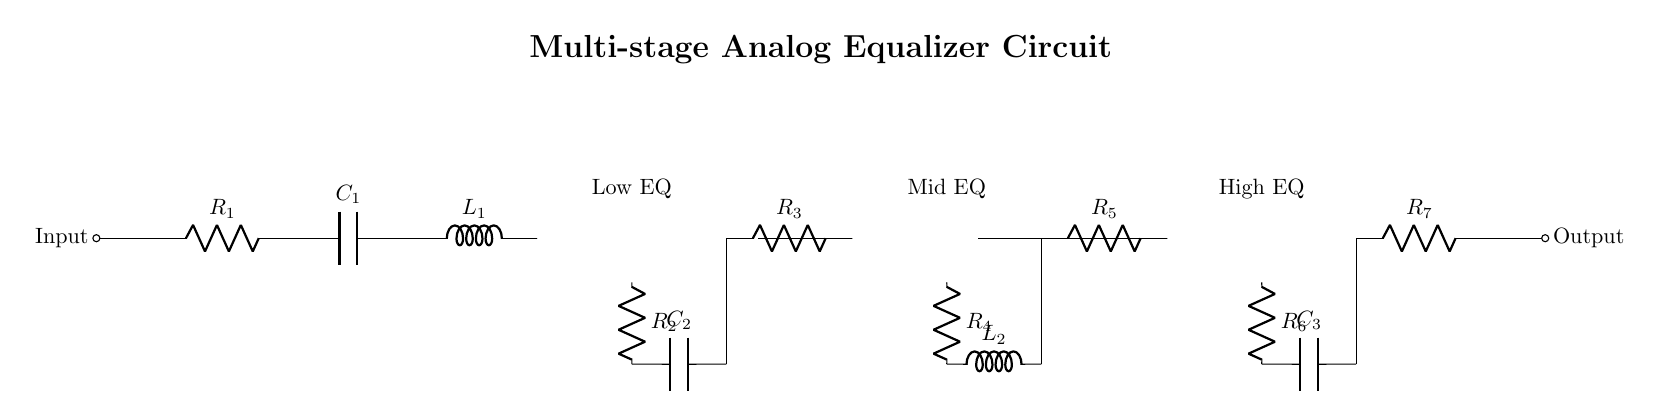What are the main components used in this equalizer circuit? The main components include resistors, capacitors, inductors, and operational amplifiers, as shown in the circuit diagram.
Answer: resistors, capacitors, inductors, operational amplifiers How many equalization stages are present in this circuit? The circuit diagram clearly shows three equalization stages: Low EQ, Mid EQ, and High EQ.
Answer: three What is the value of the first resistor in the input stage? The first resistor is labeled as R1, and while its specific value isn't provided, it is identifiable as the resistor directly connected to the input.
Answer: R1 What type of circuit is represented in this diagram? The circuit represents a multi-stage analog equalizer designed for audio frequency shaping, as indicated both by the title and the components.
Answer: multi-stage analog equalizer Why are operational amplifiers used in each EQ stage? Operational amplifiers are used to amplify the audio signal and enhance the frequency shaping capabilities of each equalization stage, allowing for greater control over the sound spectrum.
Answer: amplification and frequency shaping Which components affect the low-frequency response in this circuit? The low-frequency response is primarily influenced by the first EQ stage's components, which include the first resistor (R2) and capacitor (C2), as indicated in the circuit.
Answer: R2, C2 What does the output stage consist of? The output stage consists of a resistor (R7) connected in series, which leads to the final output point of the circuit.
Answer: R7 